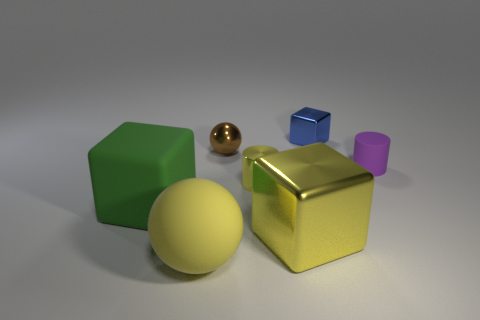What materials do the objects appear to be made of? The objects give the impression of being made from various materials. The gold-yellow cube looks shiny and metallic, suggesting it might be made of metal. The green hexahedron has a matte surface, which could indicate a plastic or painted wood material. The gold-brown sphere shares the shiny, metallic texture of the gold-yellow cube, while the small blue cube and tiny purple cylinder seem to have a plastic-like finish due to their uniform color and less reflective surface. 